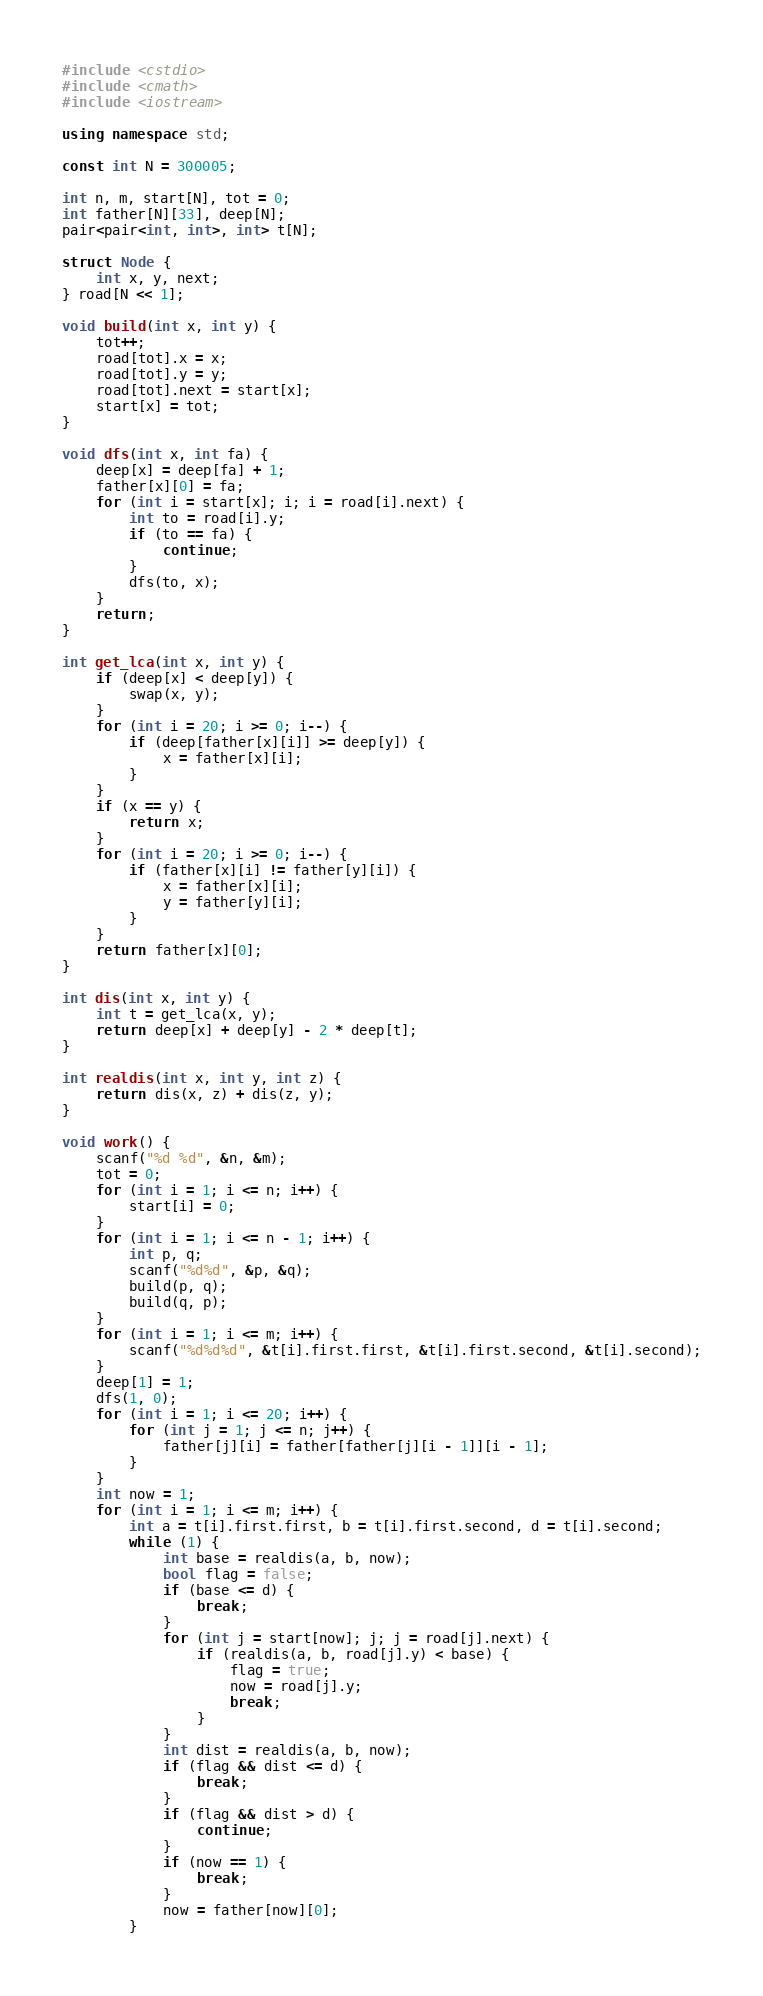<code> <loc_0><loc_0><loc_500><loc_500><_C++_>#include <cstdio>
#include <cmath>
#include <iostream>

using namespace std;

const int N = 300005;

int n, m, start[N], tot = 0;
int father[N][33], deep[N];
pair<pair<int, int>, int> t[N];

struct Node {
    int x, y, next;
} road[N << 1];

void build(int x, int y) {
    tot++;
    road[tot].x = x;
    road[tot].y = y;
    road[tot].next = start[x];
    start[x] = tot;
}

void dfs(int x, int fa) {
    deep[x] = deep[fa] + 1;
    father[x][0] = fa;
    for (int i = start[x]; i; i = road[i].next) {
        int to = road[i].y;
        if (to == fa) {
            continue;
        }
        dfs(to, x);
    }
    return;
}

int get_lca(int x, int y) {
    if (deep[x] < deep[y]) {
        swap(x, y);
    }
    for (int i = 20; i >= 0; i--) {
        if (deep[father[x][i]] >= deep[y]) {
            x = father[x][i];
        }
    }
    if (x == y) {
        return x;
    }
    for (int i = 20; i >= 0; i--) {
        if (father[x][i] != father[y][i]) {
            x = father[x][i];
            y = father[y][i];
        }
    }
    return father[x][0];
}

int dis(int x, int y) {
    int t = get_lca(x, y);
    return deep[x] + deep[y] - 2 * deep[t];
}

int realdis(int x, int y, int z) {
    return dis(x, z) + dis(z, y);
}

void work() {
    scanf("%d %d", &n, &m);
    tot = 0;
    for (int i = 1; i <= n; i++) {
        start[i] = 0;
    }
    for (int i = 1; i <= n - 1; i++) {
        int p, q;
        scanf("%d%d", &p, &q);
        build(p, q);
        build(q, p);
    }
    for (int i = 1; i <= m; i++) {
        scanf("%d%d%d", &t[i].first.first, &t[i].first.second, &t[i].second);
    }
    deep[1] = 1;
    dfs(1, 0);
    for (int i = 1; i <= 20; i++) {
        for (int j = 1; j <= n; j++) {
            father[j][i] = father[father[j][i - 1]][i - 1];
        }
    }
    int now = 1;
    for (int i = 1; i <= m; i++) {
        int a = t[i].first.first, b = t[i].first.second, d = t[i].second;
        while (1) {
            int base = realdis(a, b, now);
            bool flag = false;
            if (base <= d) {
                break;
            }
            for (int j = start[now]; j; j = road[j].next) {
                if (realdis(a, b, road[j].y) < base) {
                    flag = true;
                    now = road[j].y;
                    break;
                }
            }
            int dist = realdis(a, b, now);
            if (flag && dist <= d) {
                break;
            }
            if (flag && dist > d) {
                continue;
            }
            if (now == 1) {
                break;
            }
            now = father[now][0];
        }</code> 